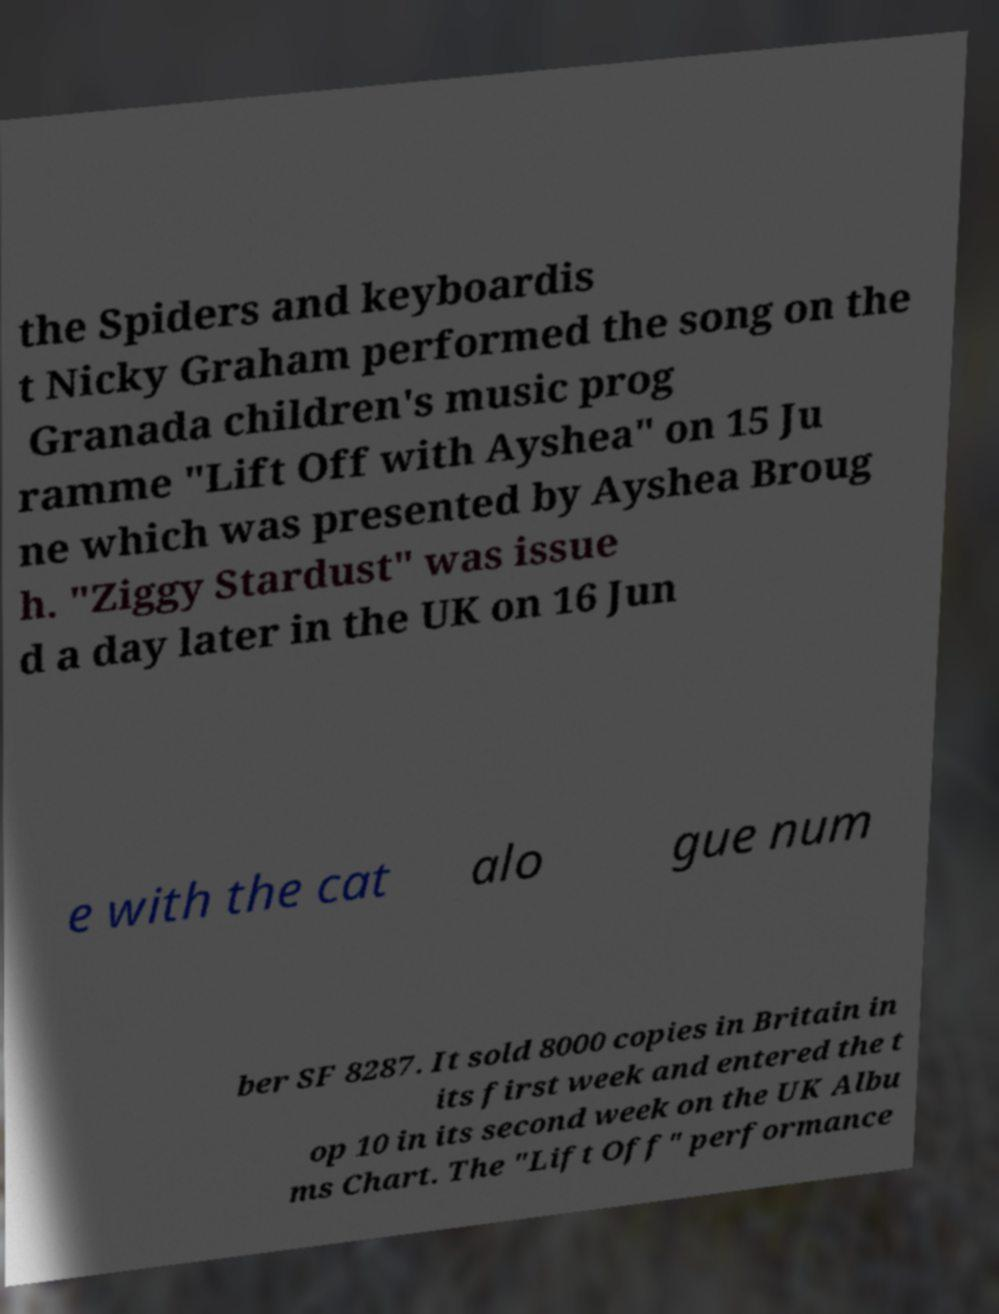What messages or text are displayed in this image? I need them in a readable, typed format. the Spiders and keyboardis t Nicky Graham performed the song on the Granada children's music prog ramme "Lift Off with Ayshea" on 15 Ju ne which was presented by Ayshea Broug h. "Ziggy Stardust" was issue d a day later in the UK on 16 Jun e with the cat alo gue num ber SF 8287. It sold 8000 copies in Britain in its first week and entered the t op 10 in its second week on the UK Albu ms Chart. The "Lift Off" performance 